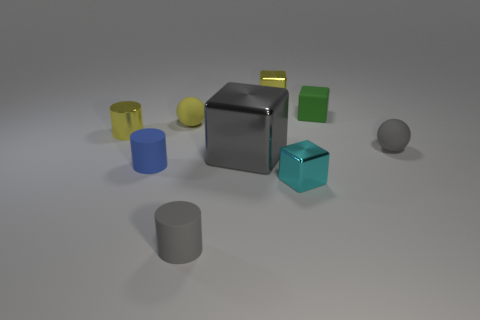How big is the metal block that is behind the tiny blue thing and in front of the green matte cube?
Your answer should be very brief. Large. How many matte cylinders are the same size as the gray ball?
Your answer should be very brief. 2. There is a metal block to the left of the metallic block that is behind the large thing; what is its size?
Your answer should be very brief. Large. There is a matte thing that is in front of the tiny cyan block; does it have the same shape as the yellow metallic object to the right of the tiny shiny cylinder?
Your answer should be very brief. No. What color is the metallic object that is right of the big thing and left of the small cyan shiny cube?
Offer a terse response. Yellow. Are there any spheres that have the same color as the large thing?
Your response must be concise. Yes. What color is the cube in front of the big gray thing?
Provide a succinct answer. Cyan. Are there any tiny green matte things that are in front of the small gray thing behind the big gray metal thing?
Keep it short and to the point. No. There is a metal cylinder; is it the same color as the small metal block that is behind the tiny blue matte cylinder?
Your answer should be compact. Yes. Are there any other large cubes that have the same material as the cyan cube?
Provide a succinct answer. Yes. 